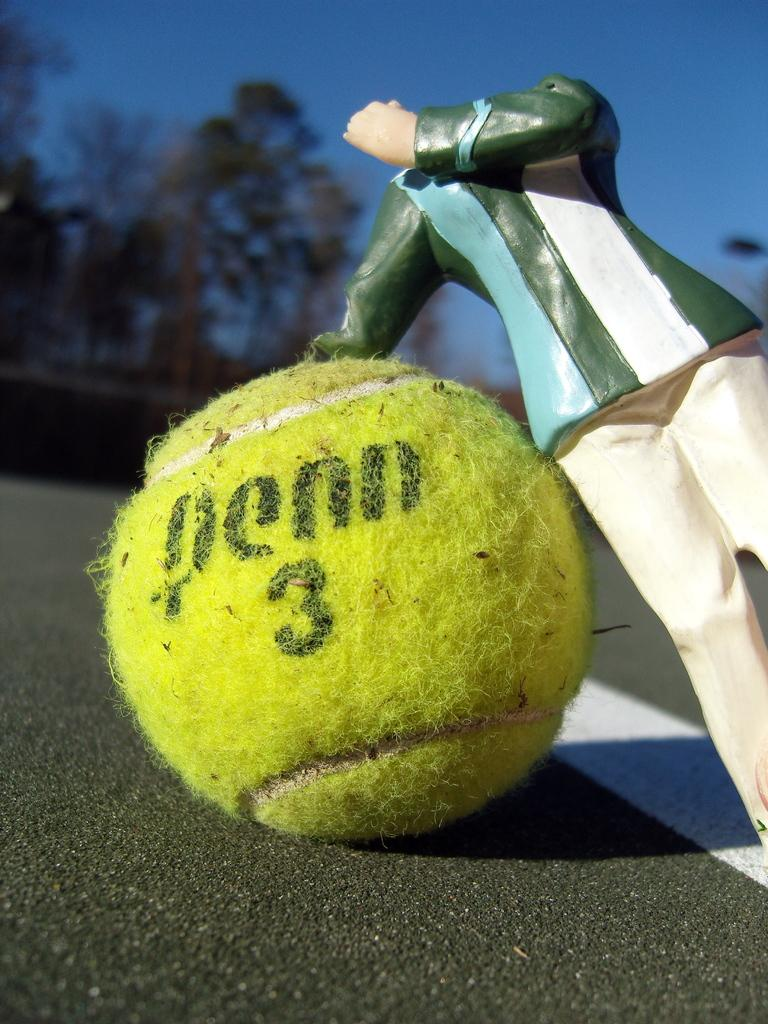<image>
Summarize the visual content of the image. a tennis ball that has the number 3 on it 